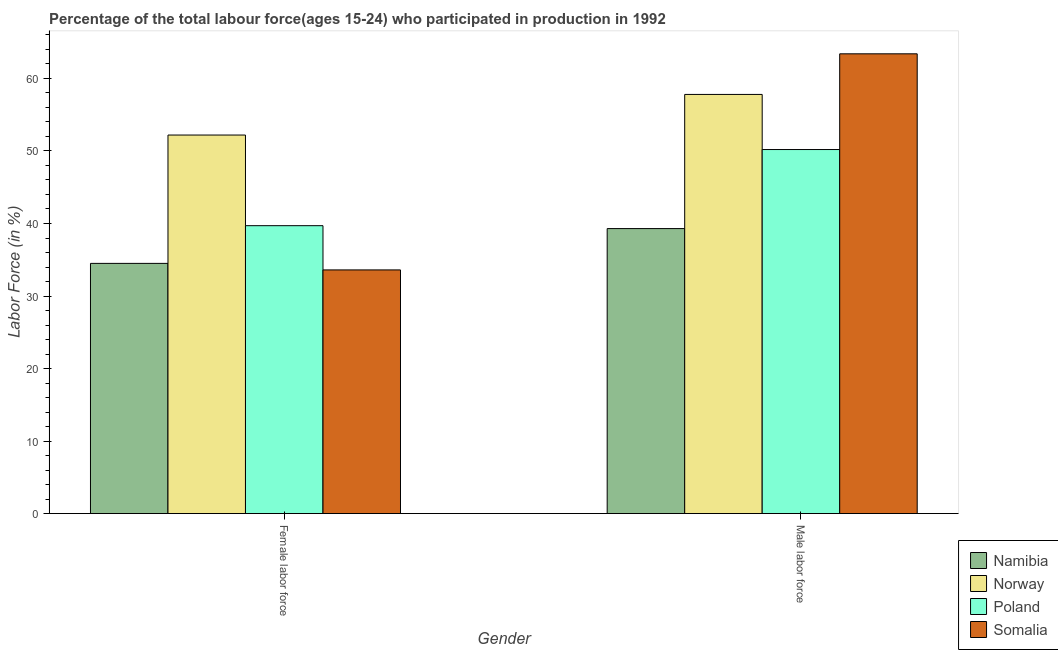How many bars are there on the 2nd tick from the right?
Offer a very short reply. 4. What is the label of the 1st group of bars from the left?
Give a very brief answer. Female labor force. What is the percentage of male labour force in Namibia?
Keep it short and to the point. 39.3. Across all countries, what is the maximum percentage of male labour force?
Your response must be concise. 63.4. Across all countries, what is the minimum percentage of female labor force?
Give a very brief answer. 33.6. In which country was the percentage of male labour force maximum?
Give a very brief answer. Somalia. In which country was the percentage of female labor force minimum?
Offer a terse response. Somalia. What is the total percentage of female labor force in the graph?
Provide a succinct answer. 160. What is the difference between the percentage of female labor force in Somalia and that in Poland?
Provide a succinct answer. -6.1. What is the difference between the percentage of female labor force in Namibia and the percentage of male labour force in Poland?
Offer a very short reply. -15.7. What is the average percentage of female labor force per country?
Ensure brevity in your answer.  40. What is the difference between the percentage of male labour force and percentage of female labor force in Namibia?
Offer a very short reply. 4.8. In how many countries, is the percentage of male labour force greater than 24 %?
Your answer should be very brief. 4. What is the ratio of the percentage of male labour force in Norway to that in Somalia?
Offer a terse response. 0.91. In how many countries, is the percentage of female labor force greater than the average percentage of female labor force taken over all countries?
Provide a succinct answer. 1. What does the 1st bar from the left in Female labor force represents?
Your response must be concise. Namibia. How many countries are there in the graph?
Give a very brief answer. 4. Are the values on the major ticks of Y-axis written in scientific E-notation?
Your answer should be very brief. No. Does the graph contain any zero values?
Offer a very short reply. No. How are the legend labels stacked?
Make the answer very short. Vertical. What is the title of the graph?
Your answer should be very brief. Percentage of the total labour force(ages 15-24) who participated in production in 1992. What is the label or title of the Y-axis?
Keep it short and to the point. Labor Force (in %). What is the Labor Force (in %) of Namibia in Female labor force?
Give a very brief answer. 34.5. What is the Labor Force (in %) in Norway in Female labor force?
Ensure brevity in your answer.  52.2. What is the Labor Force (in %) of Poland in Female labor force?
Make the answer very short. 39.7. What is the Labor Force (in %) in Somalia in Female labor force?
Give a very brief answer. 33.6. What is the Labor Force (in %) in Namibia in Male labor force?
Ensure brevity in your answer.  39.3. What is the Labor Force (in %) of Norway in Male labor force?
Give a very brief answer. 57.8. What is the Labor Force (in %) in Poland in Male labor force?
Keep it short and to the point. 50.2. What is the Labor Force (in %) in Somalia in Male labor force?
Offer a terse response. 63.4. Across all Gender, what is the maximum Labor Force (in %) in Namibia?
Offer a terse response. 39.3. Across all Gender, what is the maximum Labor Force (in %) in Norway?
Give a very brief answer. 57.8. Across all Gender, what is the maximum Labor Force (in %) in Poland?
Make the answer very short. 50.2. Across all Gender, what is the maximum Labor Force (in %) of Somalia?
Ensure brevity in your answer.  63.4. Across all Gender, what is the minimum Labor Force (in %) of Namibia?
Your answer should be compact. 34.5. Across all Gender, what is the minimum Labor Force (in %) in Norway?
Provide a succinct answer. 52.2. Across all Gender, what is the minimum Labor Force (in %) of Poland?
Offer a terse response. 39.7. Across all Gender, what is the minimum Labor Force (in %) of Somalia?
Keep it short and to the point. 33.6. What is the total Labor Force (in %) of Namibia in the graph?
Make the answer very short. 73.8. What is the total Labor Force (in %) of Norway in the graph?
Offer a very short reply. 110. What is the total Labor Force (in %) in Poland in the graph?
Offer a terse response. 89.9. What is the total Labor Force (in %) in Somalia in the graph?
Give a very brief answer. 97. What is the difference between the Labor Force (in %) in Namibia in Female labor force and that in Male labor force?
Offer a terse response. -4.8. What is the difference between the Labor Force (in %) of Somalia in Female labor force and that in Male labor force?
Provide a succinct answer. -29.8. What is the difference between the Labor Force (in %) of Namibia in Female labor force and the Labor Force (in %) of Norway in Male labor force?
Your response must be concise. -23.3. What is the difference between the Labor Force (in %) of Namibia in Female labor force and the Labor Force (in %) of Poland in Male labor force?
Provide a succinct answer. -15.7. What is the difference between the Labor Force (in %) in Namibia in Female labor force and the Labor Force (in %) in Somalia in Male labor force?
Your answer should be very brief. -28.9. What is the difference between the Labor Force (in %) of Norway in Female labor force and the Labor Force (in %) of Poland in Male labor force?
Provide a succinct answer. 2. What is the difference between the Labor Force (in %) in Norway in Female labor force and the Labor Force (in %) in Somalia in Male labor force?
Provide a short and direct response. -11.2. What is the difference between the Labor Force (in %) of Poland in Female labor force and the Labor Force (in %) of Somalia in Male labor force?
Your answer should be compact. -23.7. What is the average Labor Force (in %) of Namibia per Gender?
Your answer should be very brief. 36.9. What is the average Labor Force (in %) in Poland per Gender?
Offer a terse response. 44.95. What is the average Labor Force (in %) in Somalia per Gender?
Keep it short and to the point. 48.5. What is the difference between the Labor Force (in %) of Namibia and Labor Force (in %) of Norway in Female labor force?
Keep it short and to the point. -17.7. What is the difference between the Labor Force (in %) in Namibia and Labor Force (in %) in Poland in Female labor force?
Your response must be concise. -5.2. What is the difference between the Labor Force (in %) in Norway and Labor Force (in %) in Poland in Female labor force?
Keep it short and to the point. 12.5. What is the difference between the Labor Force (in %) of Norway and Labor Force (in %) of Somalia in Female labor force?
Offer a terse response. 18.6. What is the difference between the Labor Force (in %) in Namibia and Labor Force (in %) in Norway in Male labor force?
Your answer should be very brief. -18.5. What is the difference between the Labor Force (in %) of Namibia and Labor Force (in %) of Poland in Male labor force?
Provide a short and direct response. -10.9. What is the difference between the Labor Force (in %) in Namibia and Labor Force (in %) in Somalia in Male labor force?
Provide a short and direct response. -24.1. What is the difference between the Labor Force (in %) in Norway and Labor Force (in %) in Somalia in Male labor force?
Your answer should be very brief. -5.6. What is the ratio of the Labor Force (in %) of Namibia in Female labor force to that in Male labor force?
Keep it short and to the point. 0.88. What is the ratio of the Labor Force (in %) of Norway in Female labor force to that in Male labor force?
Offer a very short reply. 0.9. What is the ratio of the Labor Force (in %) of Poland in Female labor force to that in Male labor force?
Keep it short and to the point. 0.79. What is the ratio of the Labor Force (in %) of Somalia in Female labor force to that in Male labor force?
Give a very brief answer. 0.53. What is the difference between the highest and the second highest Labor Force (in %) in Poland?
Your answer should be very brief. 10.5. What is the difference between the highest and the second highest Labor Force (in %) in Somalia?
Give a very brief answer. 29.8. What is the difference between the highest and the lowest Labor Force (in %) in Norway?
Your answer should be compact. 5.6. What is the difference between the highest and the lowest Labor Force (in %) of Somalia?
Your response must be concise. 29.8. 